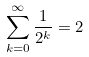Convert formula to latex. <formula><loc_0><loc_0><loc_500><loc_500>\sum _ { k = 0 } ^ { \infty } \frac { 1 } { 2 ^ { k } } = 2</formula> 